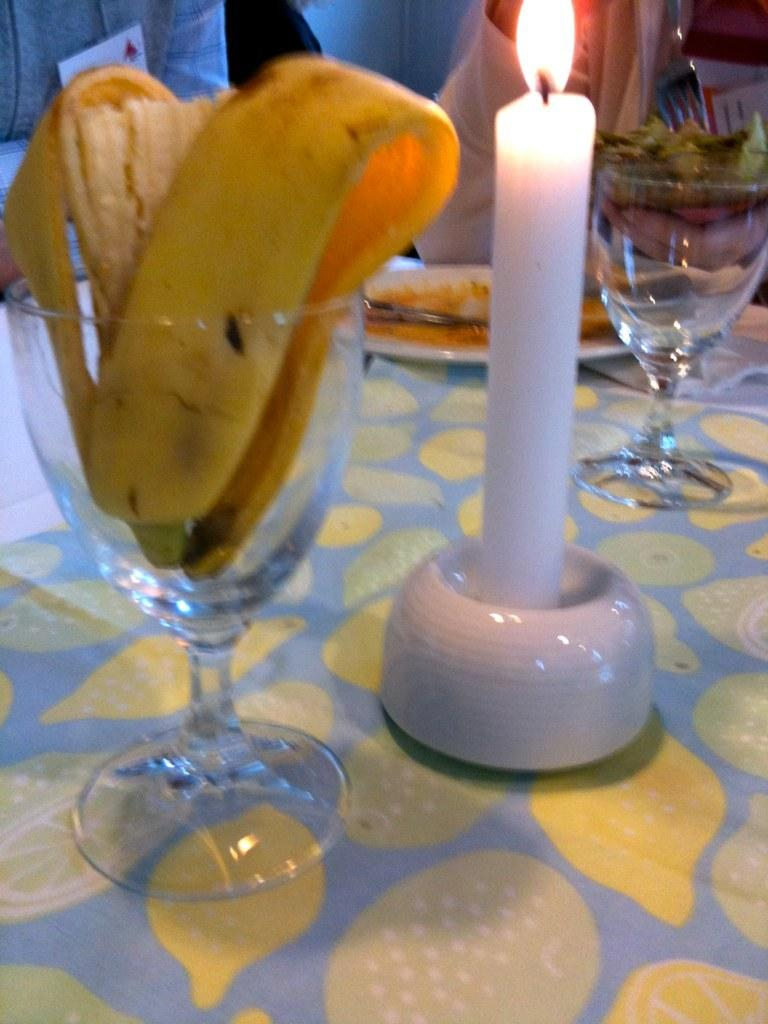What is the main object in the center of the image? There is a table in the center of the image. What can be found on the table? There are glasses, food items, and a candle on the table. Are there any people in the image? Yes, there are people at the top side of the image. Where is the patch located on the table in the image? There is no patch present on the table in the image. What type of scissors can be seen being used by the grandfather in the image? There is no grandfather or scissors present in the image. 